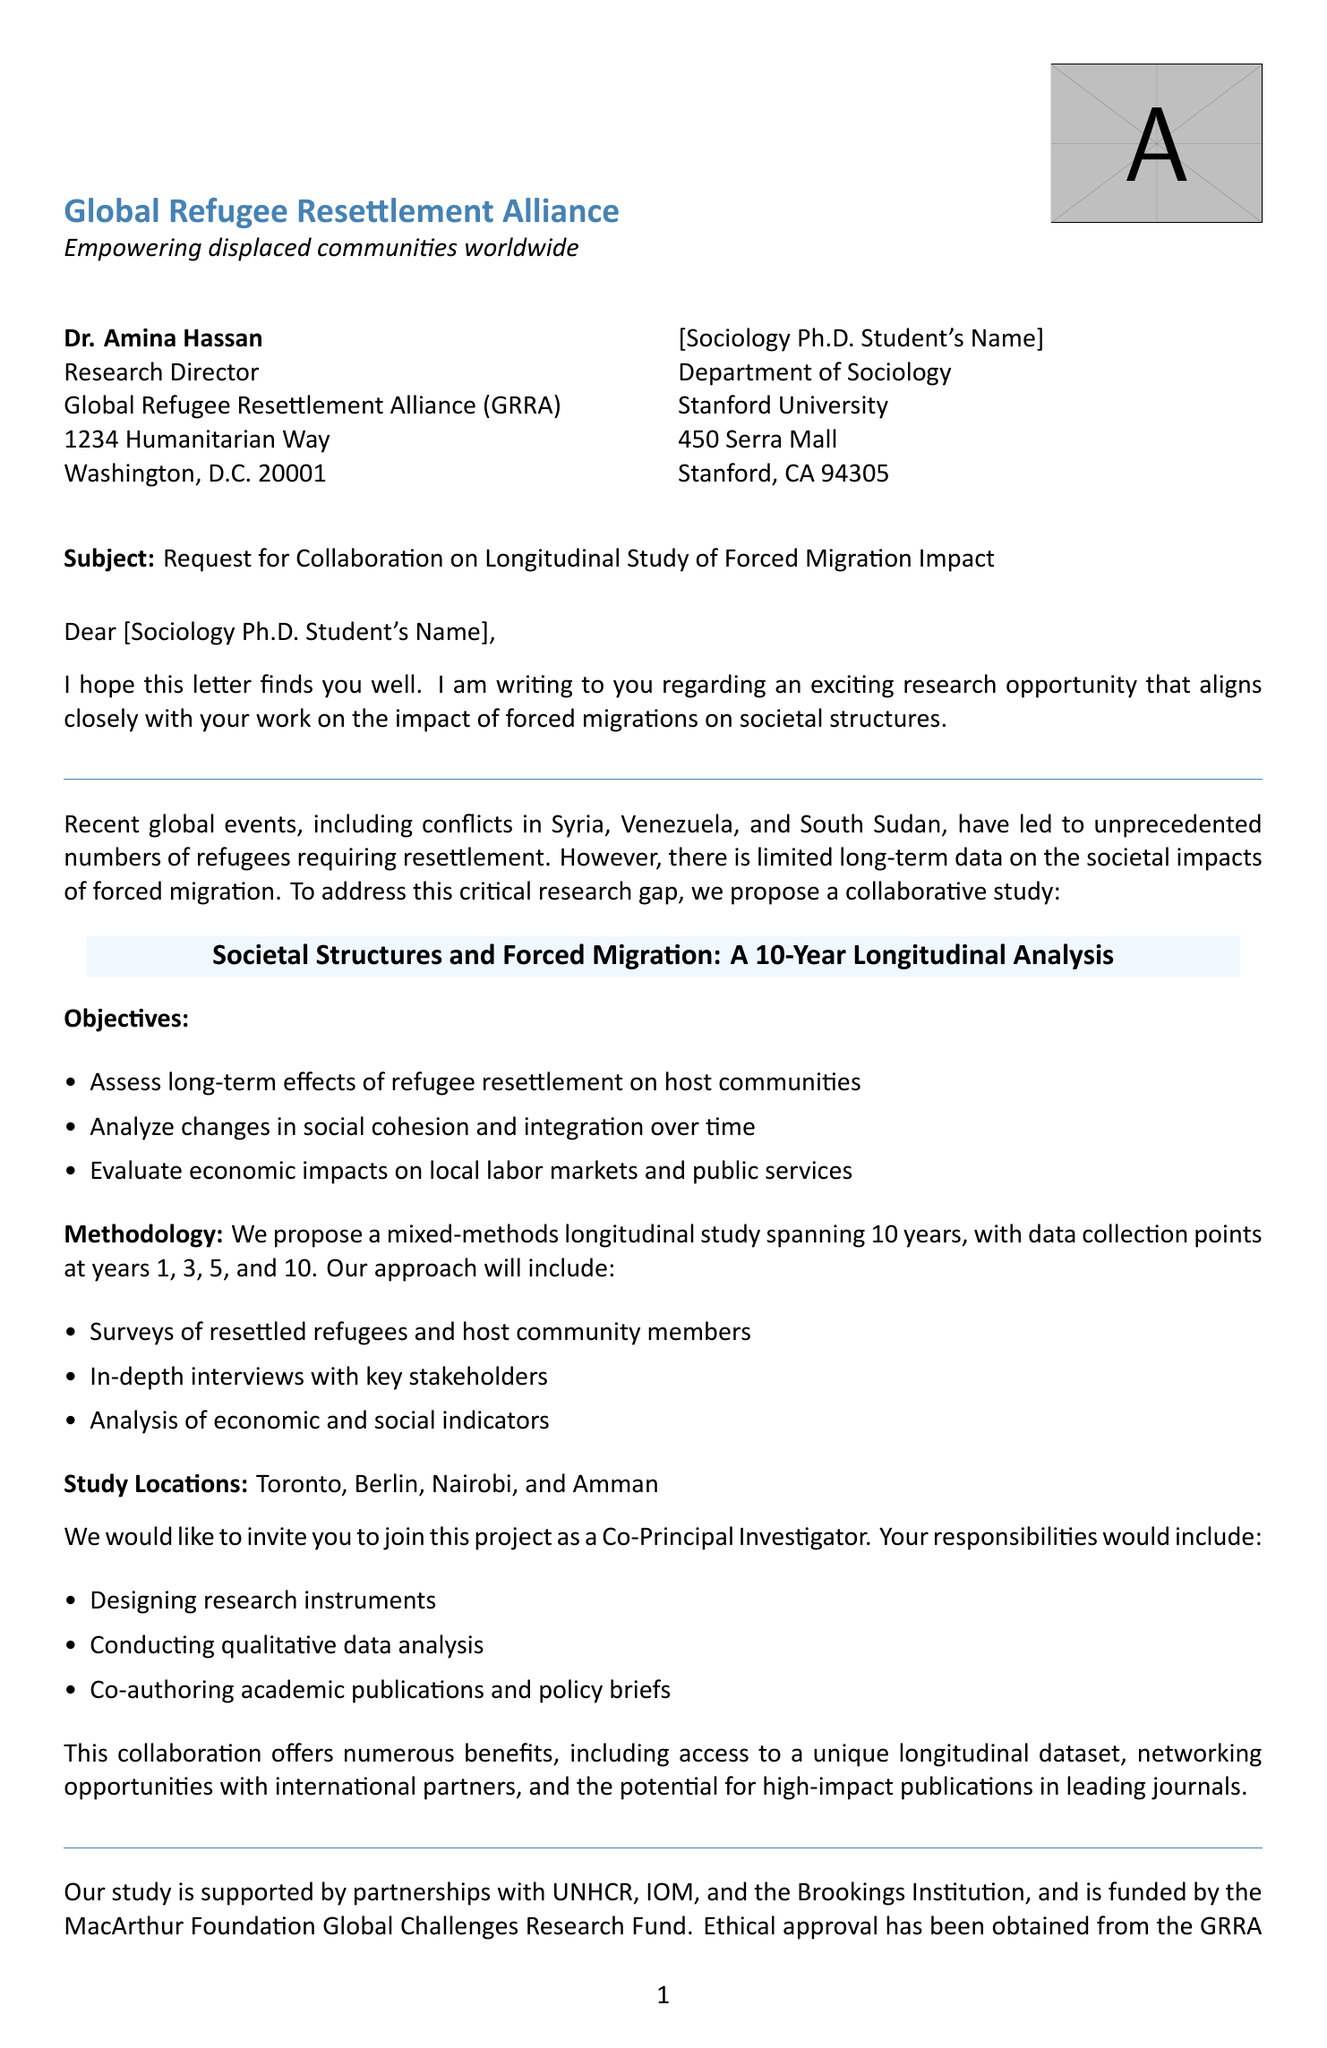What is the name of the sender? The sender of the letter is identified as Dr. Amina Hassan.
Answer: Dr. Amina Hassan What is the subject of the letter? The subject provides the main focus of the letter and is "Request for Collaboration on Longitudinal Study of Forced Migration Impact."
Answer: Request for Collaboration on Longitudinal Study of Forced Migration Impact What are the study locations mentioned in the letter? The letter lists four study locations: Toronto, Berlin, Nairobi, and Amman.
Answer: Toronto, Berlin, Nairobi, Amman What is the role offered to the recipient? The letter states that the recipient is offered the role of Co-Principal Investigator.
Answer: Co-Principal Investigator What is the response deadline specified in the letter? The letter requests a response within two weeks of receipt.
Answer: Two weeks What are two objectives of the proposed study? The section outlines several objectives, two of which are to assess long-term effects of refugee resettlement on host communities and analyze changes in social cohesion and integration over time.
Answer: Assess long-term effects of refugee resettlement on host communities, analyze changes in social cohesion and integration over time Who funded the study? The funding source for the study is mentioned as the MacArthur Foundation Global Challenges Research Fund.
Answer: MacArthur Foundation Global Challenges Research Fund What is one benefit of collaborating on this study? The letter outlines several benefits, one being access to a unique longitudinal dataset.
Answer: Access to unique longitudinal dataset What methodology is proposed for the study? The letter indicates that a mixed-methods longitudinal study will be conducted.
Answer: Mixed-methods longitudinal study 